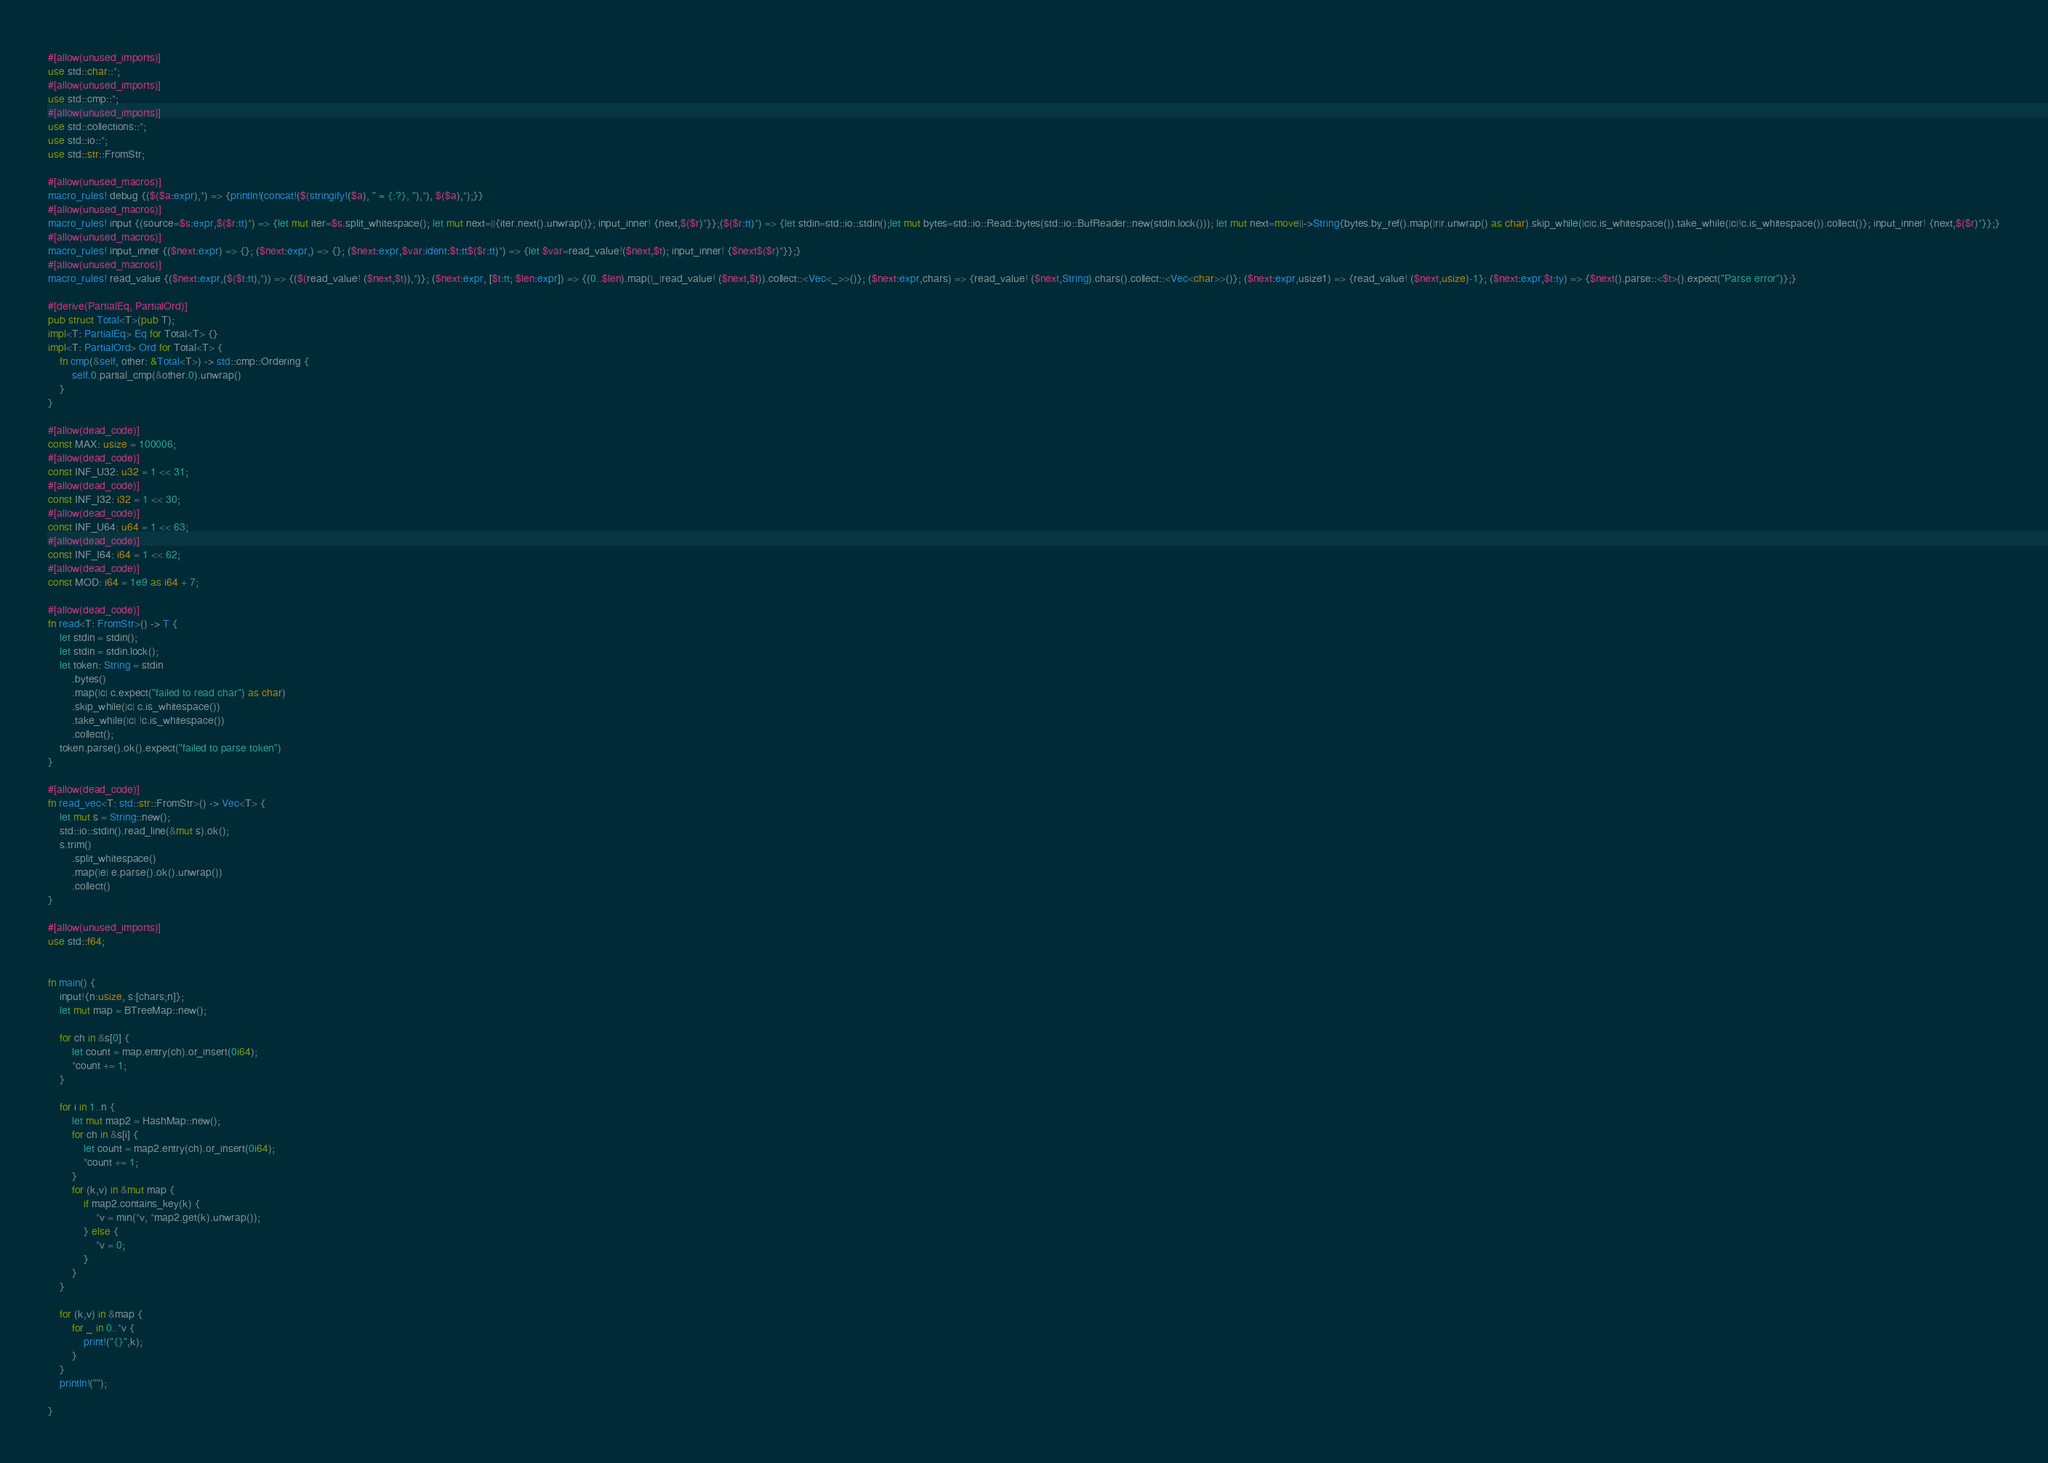Convert code to text. <code><loc_0><loc_0><loc_500><loc_500><_Rust_>#[allow(unused_imports)]
use std::char::*;
#[allow(unused_imports)]
use std::cmp::*;
#[allow(unused_imports)]
use std::collections::*;
use std::io::*;
use std::str::FromStr;

#[allow(unused_macros)]
macro_rules! debug {($($a:expr),*) => {println!(concat!($(stringify!($a), " = {:?}, "),*), $($a),*);}}
#[allow(unused_macros)]
macro_rules! input {(source=$s:expr,$($r:tt)*) => {let mut iter=$s.split_whitespace(); let mut next=||{iter.next().unwrap()}; input_inner! {next,$($r)*}};($($r:tt)*) => {let stdin=std::io::stdin();let mut bytes=std::io::Read::bytes(std::io::BufReader::new(stdin.lock())); let mut next=move||->String{bytes.by_ref().map(|r|r.unwrap() as char).skip_while(|c|c.is_whitespace()).take_while(|c|!c.is_whitespace()).collect()}; input_inner! {next,$($r)*}};}
#[allow(unused_macros)]
macro_rules! input_inner {($next:expr) => {}; ($next:expr,) => {}; ($next:expr,$var:ident:$t:tt$($r:tt)*) => {let $var=read_value!($next,$t); input_inner! {$next$($r)*}};}
#[allow(unused_macros)]
macro_rules! read_value {($next:expr,($($t:tt),*)) => {($(read_value! ($next,$t)),*)}; ($next:expr, [$t:tt; $len:expr]) => {(0..$len).map(|_|read_value! ($next,$t)).collect::<Vec<_>>()}; ($next:expr,chars) => {read_value! ($next,String).chars().collect::<Vec<char>>()}; ($next:expr,usize1) => {read_value! ($next,usize)-1}; ($next:expr,$t:ty) => {$next().parse::<$t>().expect("Parse error")};}

#[derive(PartialEq, PartialOrd)]
pub struct Total<T>(pub T);
impl<T: PartialEq> Eq for Total<T> {}
impl<T: PartialOrd> Ord for Total<T> {
    fn cmp(&self, other: &Total<T>) -> std::cmp::Ordering {
        self.0.partial_cmp(&other.0).unwrap()
    }
}

#[allow(dead_code)]
const MAX: usize = 100006;
#[allow(dead_code)]
const INF_U32: u32 = 1 << 31;
#[allow(dead_code)]
const INF_I32: i32 = 1 << 30;
#[allow(dead_code)]
const INF_U64: u64 = 1 << 63;
#[allow(dead_code)]
const INF_I64: i64 = 1 << 62;
#[allow(dead_code)]
const MOD: i64 = 1e9 as i64 + 7;

#[allow(dead_code)]
fn read<T: FromStr>() -> T {
    let stdin = stdin();
    let stdin = stdin.lock();
    let token: String = stdin
        .bytes()
        .map(|c| c.expect("failed to read char") as char)
        .skip_while(|c| c.is_whitespace())
        .take_while(|c| !c.is_whitespace())
        .collect();
    token.parse().ok().expect("failed to parse token")
}

#[allow(dead_code)]
fn read_vec<T: std::str::FromStr>() -> Vec<T> {
    let mut s = String::new();
    std::io::stdin().read_line(&mut s).ok();
    s.trim()
        .split_whitespace()
        .map(|e| e.parse().ok().unwrap())
        .collect()
}

#[allow(unused_imports)]
use std::f64;


fn main() {
    input!{n:usize, s:[chars;n]};
    let mut map = BTreeMap::new();

    for ch in &s[0] {
        let count = map.entry(ch).or_insert(0i64);
        *count += 1;
    }

    for i in 1..n {
        let mut map2 = HashMap::new();
        for ch in &s[i] {
            let count = map2.entry(ch).or_insert(0i64);
            *count += 1;
        }
        for (k,v) in &mut map {
            if map2.contains_key(k) {
                *v = min(*v, *map2.get(k).unwrap());
            } else {
                *v = 0;
            }
        }
    }

    for (k,v) in &map {
        for _ in 0..*v {
            print!("{}",k);
        }
    }
    println!("");

}</code> 